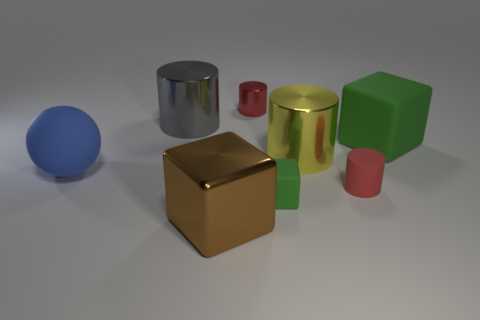Subtract all brown cylinders. Subtract all brown cubes. How many cylinders are left? 4 Add 2 small cyan metal cylinders. How many objects exist? 10 Subtract all blocks. How many objects are left? 5 Add 6 yellow shiny objects. How many yellow shiny objects exist? 7 Subtract 0 red cubes. How many objects are left? 8 Subtract all yellow things. Subtract all big gray shiny cylinders. How many objects are left? 6 Add 1 big yellow metal cylinders. How many big yellow metal cylinders are left? 2 